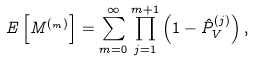<formula> <loc_0><loc_0><loc_500><loc_500>E \left [ M ^ { ( _ { m } ) } \right ] = \sum _ { m = 0 } ^ { \infty } \prod _ { j = 1 } ^ { m + 1 } \left ( 1 - \hat { P } _ { V } ^ { ( j ) } \right ) ,</formula> 